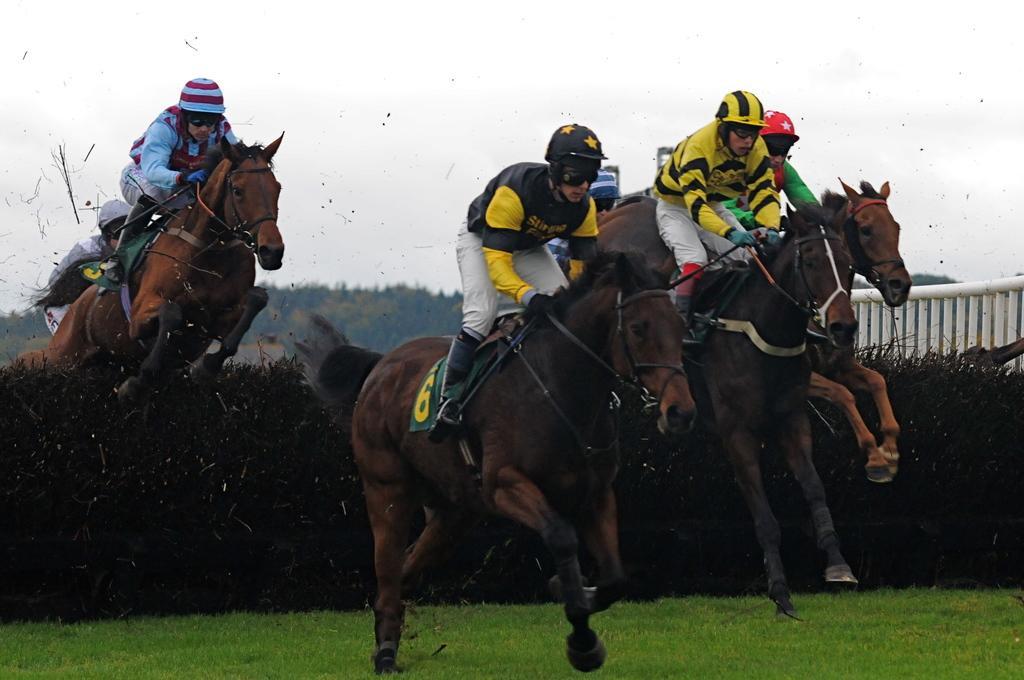In one or two sentences, can you explain what this image depicts? In the picture we can see a grass surface on it, we can see some people are riding the horses sitting on it and they are in sports wear and helmets and behind them, we can see a man jumping with a horse from the bushes and in the background we can see many trees and the sky. 